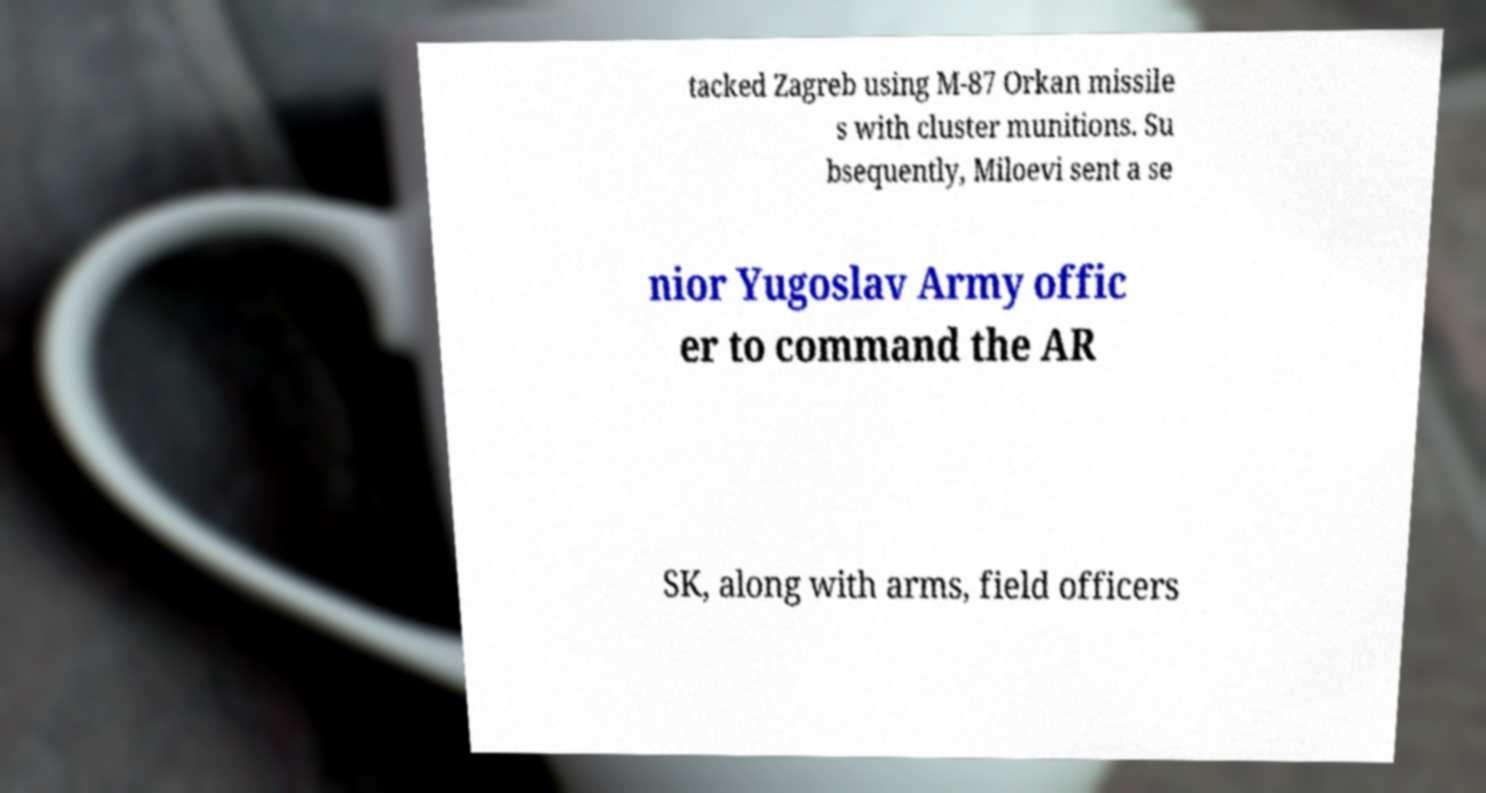Please read and relay the text visible in this image. What does it say? tacked Zagreb using M-87 Orkan missile s with cluster munitions. Su bsequently, Miloevi sent a se nior Yugoslav Army offic er to command the AR SK, along with arms, field officers 